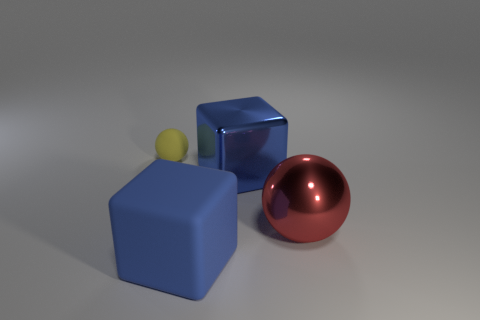Is there a cube of the same color as the big rubber object?
Your answer should be compact. Yes. Is the color of the big block right of the blue matte cube the same as the large matte thing?
Provide a short and direct response. Yes. There is another cube that is the same color as the rubber block; what is its material?
Keep it short and to the point. Metal. There is another cube that is the same color as the metal cube; what is its size?
Your response must be concise. Large. There is a big cube that is behind the large red metallic ball; does it have the same color as the matte thing that is on the right side of the yellow ball?
Offer a terse response. Yes. What number of other objects are the same shape as the tiny yellow thing?
Your answer should be very brief. 1. Is the sphere that is on the left side of the big blue matte thing made of the same material as the large block that is in front of the large sphere?
Provide a short and direct response. Yes. There is a thing that is behind the red thing and left of the blue metal block; what is its shape?
Make the answer very short. Sphere. What is the object that is both left of the blue metal block and in front of the large blue metal object made of?
Your answer should be compact. Rubber. What shape is the blue object that is the same material as the red thing?
Give a very brief answer. Cube. 